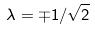<formula> <loc_0><loc_0><loc_500><loc_500>\lambda = \mp 1 / \sqrt { 2 }</formula> 